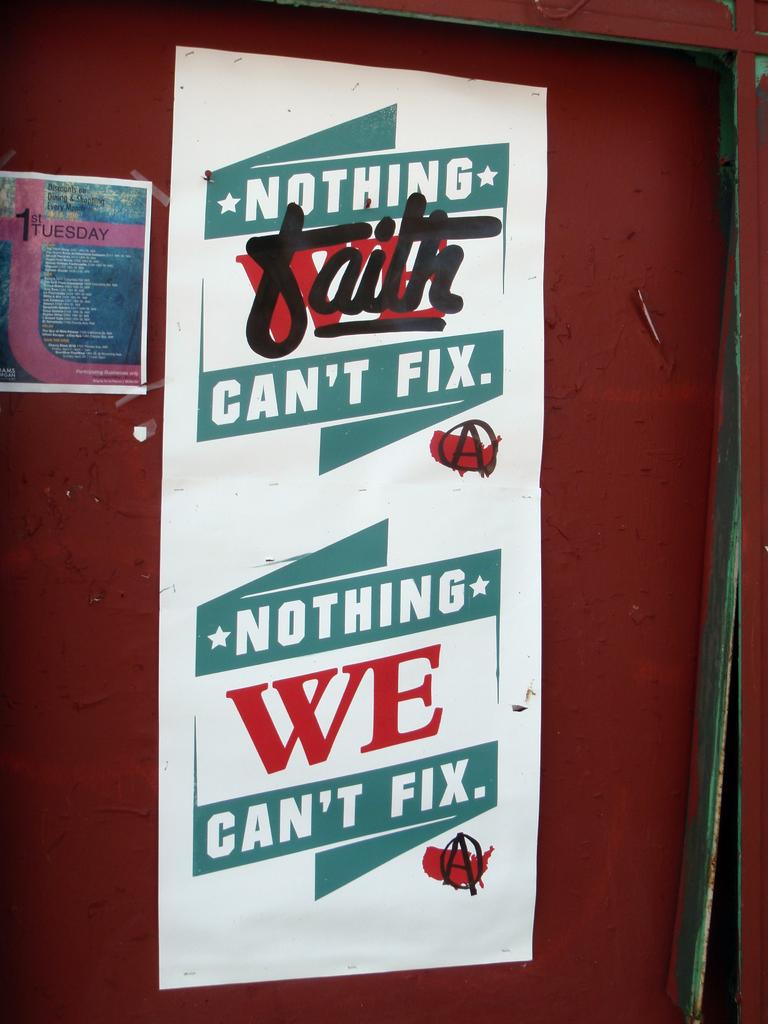What can't this sign fix?
Your answer should be very brief. Nothing. What is the word in the middle of the top slogan?
Ensure brevity in your answer.  Faith. 